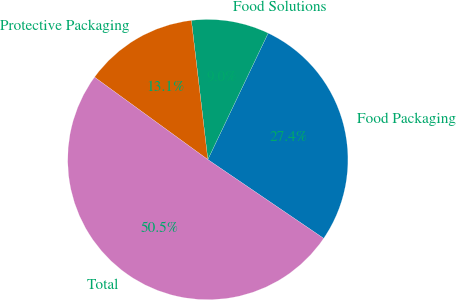Convert chart. <chart><loc_0><loc_0><loc_500><loc_500><pie_chart><fcel>Food Packaging<fcel>Food Solutions<fcel>Protective Packaging<fcel>Total<nl><fcel>27.42%<fcel>8.96%<fcel>13.12%<fcel>50.5%<nl></chart> 